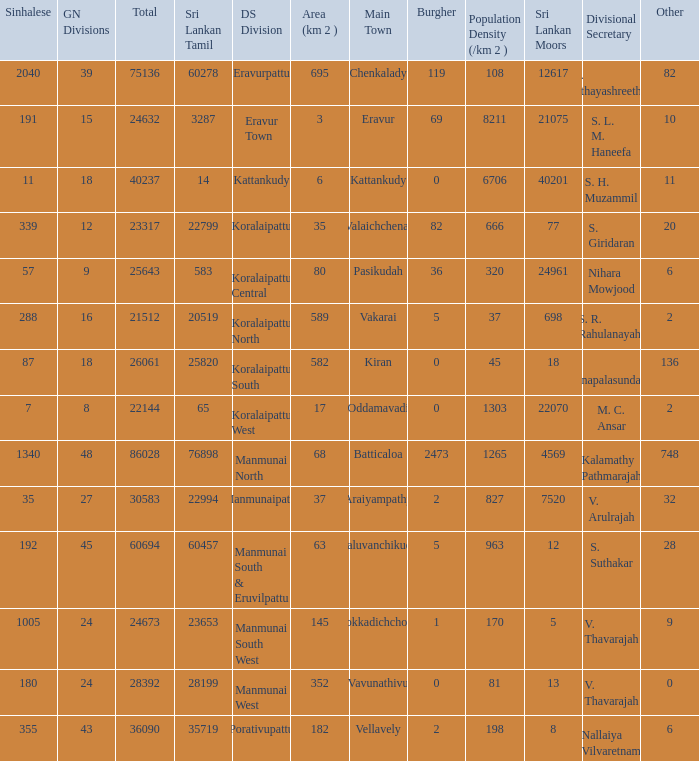What is the name of the DS division where the divisional secretary is S. H. Muzammil? Kattankudy. 